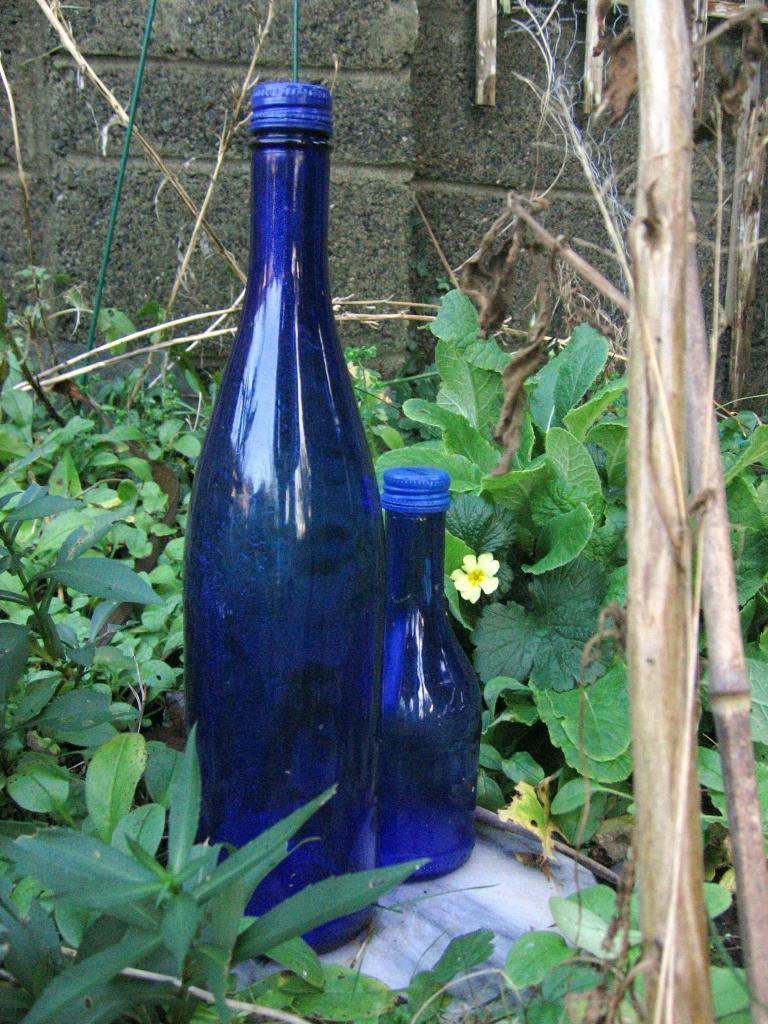Please provide a concise description of this image. In the image in the center we can see two bottles. These bottles were surrounded by plants,and back of this bottle there is a wall. 